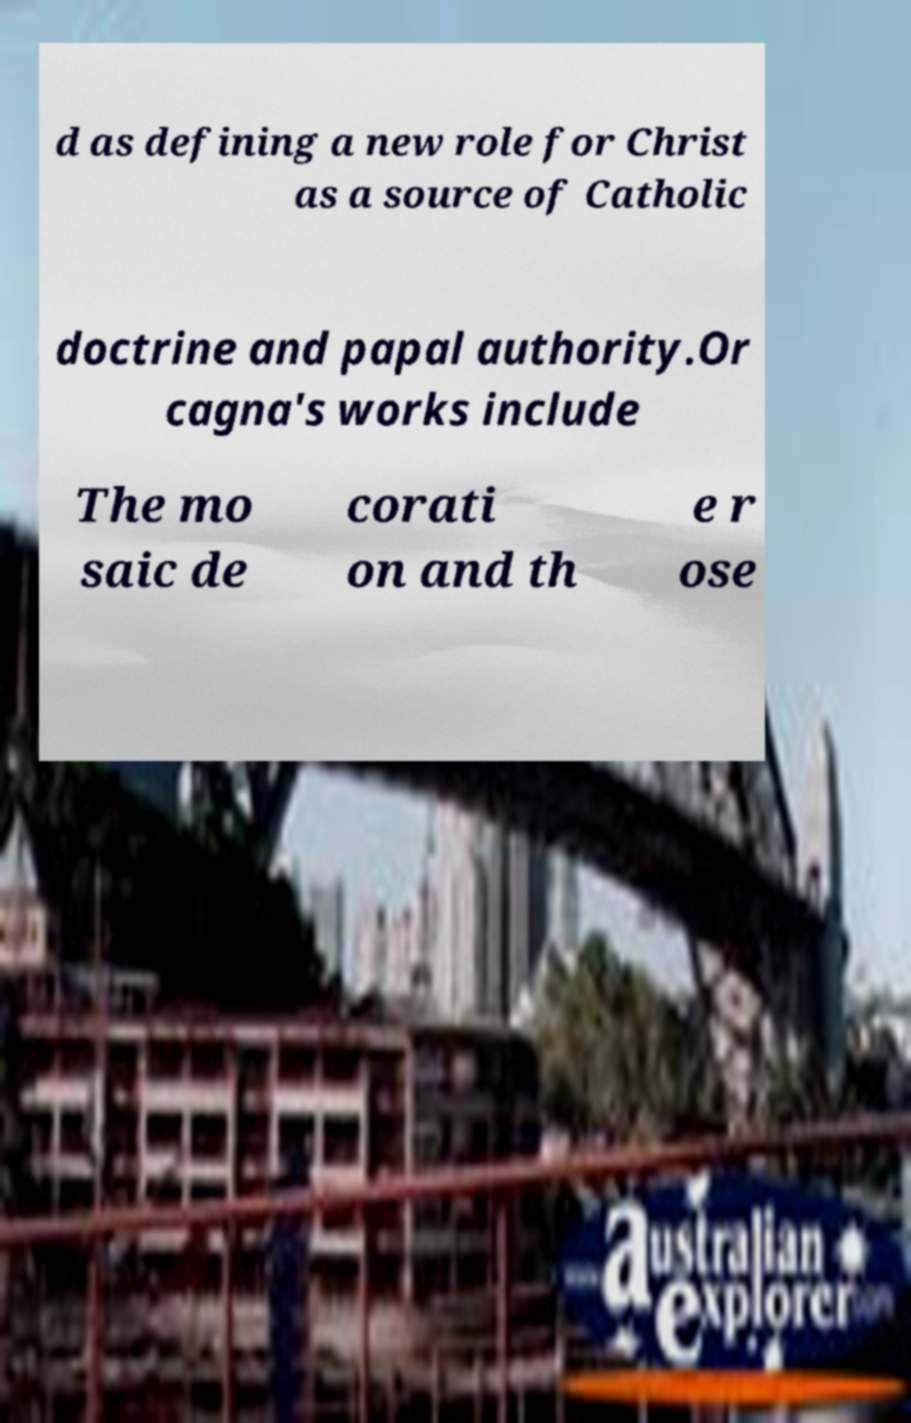Please identify and transcribe the text found in this image. d as defining a new role for Christ as a source of Catholic doctrine and papal authority.Or cagna's works include The mo saic de corati on and th e r ose 